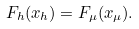Convert formula to latex. <formula><loc_0><loc_0><loc_500><loc_500>F _ { h } ( x _ { h } ) = F _ { \mu } ( x _ { \mu } ) .</formula> 